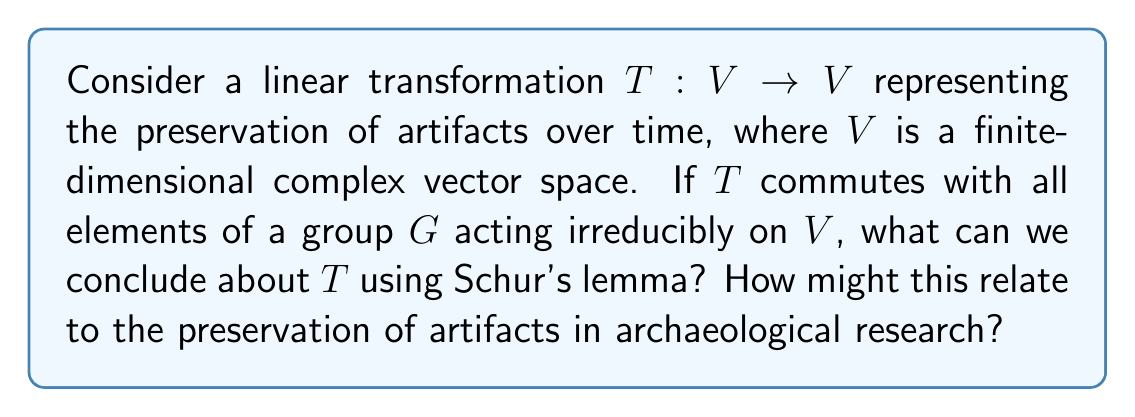Give your solution to this math problem. Let's approach this step-by-step:

1) First, recall Schur's lemma: If $V$ is an irreducible representation of a group $G$, and $T: V \to V$ is a linear transformation that commutes with all elements of $G$, then $T$ is a scalar multiple of the identity transformation.

2) In our case, we're given that $T$ commutes with all elements of $G$, and $G$ acts irreducibly on $V$. This means we can directly apply Schur's lemma.

3) Therefore, we can conclude that $T = \lambda I$, where $\lambda$ is a complex scalar and $I$ is the identity transformation.

4) This means that $T$ acts uniformly on all vectors in $V$, scaling them by the same factor $\lambda$.

5) In the context of artifact preservation:
   - $V$ could represent the state space of artifacts
   - The action of $G$ could represent various preservation techniques
   - $T$ represents the overall effect of time on the artifacts

6) The fact that $T$ is a scalar multiple of the identity implies that all aspects of the artifacts are affected uniformly over time.

7) If $|\lambda| < 1$, it would indicate decay over time.
   If $|\lambda| = 1$, it would indicate perfect preservation.
   If $|\lambda| > 1$, it would indicate improvement over time (unlikely in most archaeological contexts).

8) This uniform effect suggests that our preservation techniques (represented by $G$) are equally effective for all aspects of the artifacts, which is a desirable outcome in archaeological conservation.
Answer: $T = \lambda I$, where $\lambda$ is a complex scalar and $I$ is the identity transformation. 